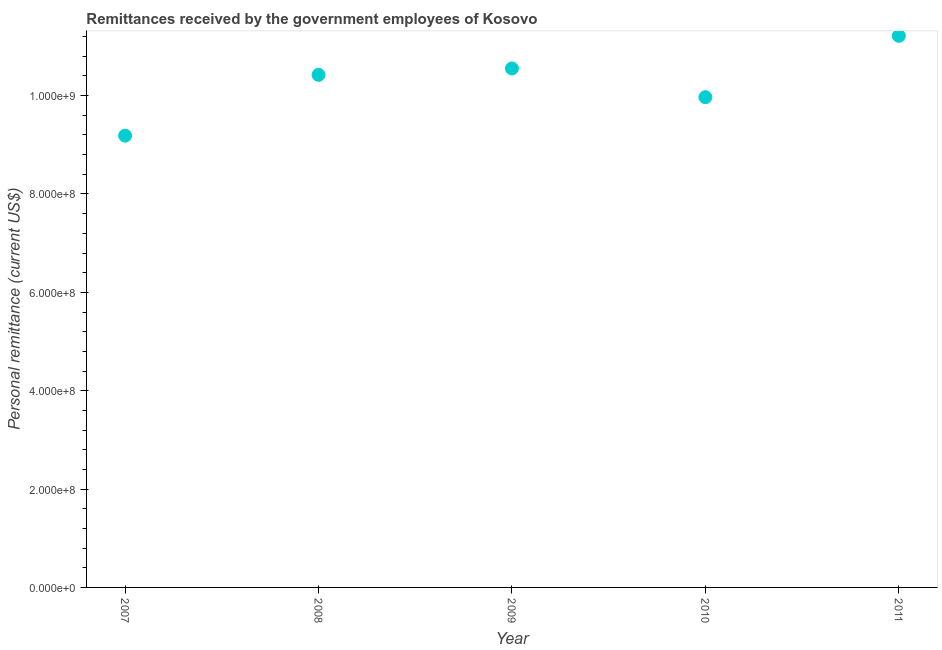What is the personal remittances in 2010?
Your response must be concise. 9.97e+08. Across all years, what is the maximum personal remittances?
Make the answer very short. 1.12e+09. Across all years, what is the minimum personal remittances?
Make the answer very short. 9.19e+08. What is the sum of the personal remittances?
Provide a succinct answer. 5.13e+09. What is the difference between the personal remittances in 2008 and 2010?
Provide a short and direct response. 4.54e+07. What is the average personal remittances per year?
Provide a short and direct response. 1.03e+09. What is the median personal remittances?
Offer a terse response. 1.04e+09. What is the ratio of the personal remittances in 2009 to that in 2010?
Your answer should be compact. 1.06. What is the difference between the highest and the second highest personal remittances?
Make the answer very short. 6.64e+07. Is the sum of the personal remittances in 2007 and 2011 greater than the maximum personal remittances across all years?
Your answer should be very brief. Yes. What is the difference between the highest and the lowest personal remittances?
Your answer should be very brief. 2.03e+08. In how many years, is the personal remittances greater than the average personal remittances taken over all years?
Ensure brevity in your answer.  3. How many dotlines are there?
Your answer should be compact. 1. What is the difference between two consecutive major ticks on the Y-axis?
Give a very brief answer. 2.00e+08. What is the title of the graph?
Your answer should be very brief. Remittances received by the government employees of Kosovo. What is the label or title of the Y-axis?
Offer a terse response. Personal remittance (current US$). What is the Personal remittance (current US$) in 2007?
Offer a terse response. 9.19e+08. What is the Personal remittance (current US$) in 2008?
Ensure brevity in your answer.  1.04e+09. What is the Personal remittance (current US$) in 2009?
Offer a very short reply. 1.06e+09. What is the Personal remittance (current US$) in 2010?
Your response must be concise. 9.97e+08. What is the Personal remittance (current US$) in 2011?
Ensure brevity in your answer.  1.12e+09. What is the difference between the Personal remittance (current US$) in 2007 and 2008?
Give a very brief answer. -1.24e+08. What is the difference between the Personal remittance (current US$) in 2007 and 2009?
Your response must be concise. -1.37e+08. What is the difference between the Personal remittance (current US$) in 2007 and 2010?
Your answer should be compact. -7.82e+07. What is the difference between the Personal remittance (current US$) in 2007 and 2011?
Ensure brevity in your answer.  -2.03e+08. What is the difference between the Personal remittance (current US$) in 2008 and 2009?
Your answer should be compact. -1.30e+07. What is the difference between the Personal remittance (current US$) in 2008 and 2010?
Your answer should be compact. 4.54e+07. What is the difference between the Personal remittance (current US$) in 2008 and 2011?
Ensure brevity in your answer.  -7.93e+07. What is the difference between the Personal remittance (current US$) in 2009 and 2010?
Your answer should be compact. 5.84e+07. What is the difference between the Personal remittance (current US$) in 2009 and 2011?
Ensure brevity in your answer.  -6.64e+07. What is the difference between the Personal remittance (current US$) in 2010 and 2011?
Give a very brief answer. -1.25e+08. What is the ratio of the Personal remittance (current US$) in 2007 to that in 2008?
Provide a short and direct response. 0.88. What is the ratio of the Personal remittance (current US$) in 2007 to that in 2009?
Your answer should be very brief. 0.87. What is the ratio of the Personal remittance (current US$) in 2007 to that in 2010?
Make the answer very short. 0.92. What is the ratio of the Personal remittance (current US$) in 2007 to that in 2011?
Keep it short and to the point. 0.82. What is the ratio of the Personal remittance (current US$) in 2008 to that in 2010?
Your response must be concise. 1.05. What is the ratio of the Personal remittance (current US$) in 2008 to that in 2011?
Your answer should be compact. 0.93. What is the ratio of the Personal remittance (current US$) in 2009 to that in 2010?
Provide a succinct answer. 1.06. What is the ratio of the Personal remittance (current US$) in 2009 to that in 2011?
Make the answer very short. 0.94. What is the ratio of the Personal remittance (current US$) in 2010 to that in 2011?
Provide a short and direct response. 0.89. 